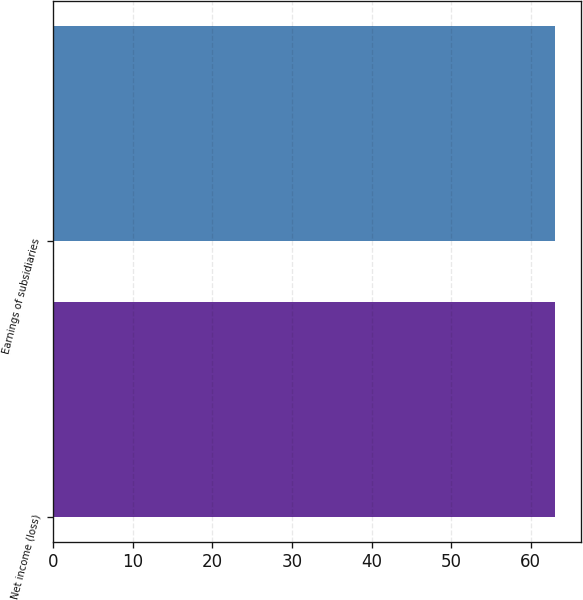Convert chart to OTSL. <chart><loc_0><loc_0><loc_500><loc_500><bar_chart><fcel>Net income (loss)<fcel>Earnings of subsidiaries<nl><fcel>63<fcel>63.1<nl></chart> 